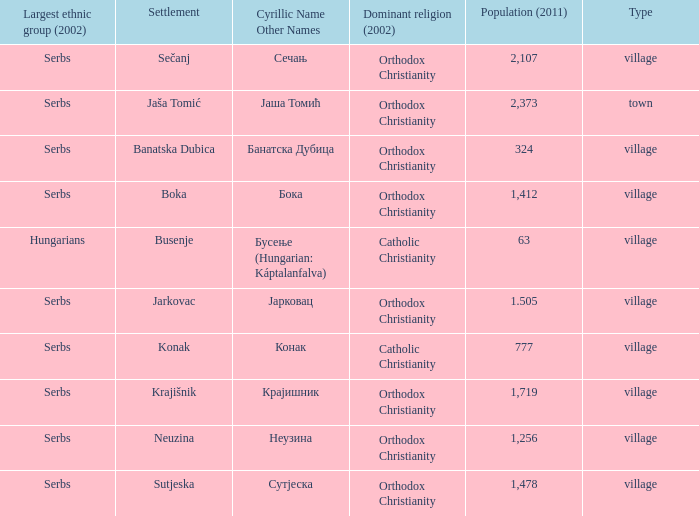What town has the population of 777? Конак. 